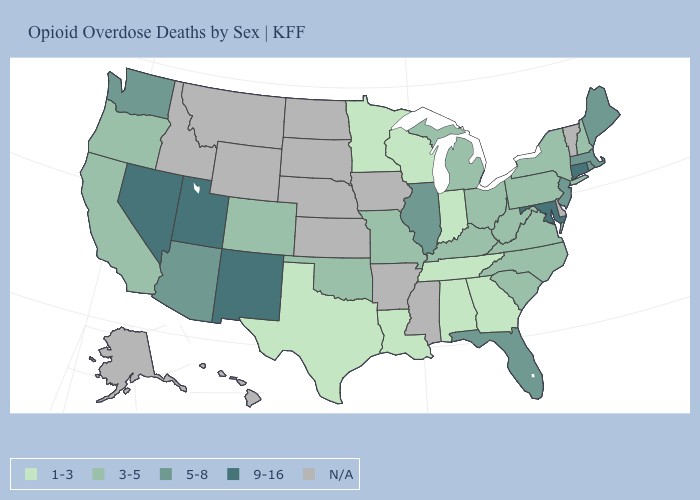What is the value of Connecticut?
Concise answer only. 9-16. Which states have the highest value in the USA?
Keep it brief. Connecticut, Maryland, Nevada, New Mexico, Utah. Does the first symbol in the legend represent the smallest category?
Quick response, please. Yes. What is the value of New York?
Short answer required. 3-5. Which states hav the highest value in the West?
Quick response, please. Nevada, New Mexico, Utah. Name the states that have a value in the range N/A?
Quick response, please. Alaska, Arkansas, Delaware, Hawaii, Idaho, Iowa, Kansas, Mississippi, Montana, Nebraska, North Dakota, South Dakota, Vermont, Wyoming. Among the states that border Kansas , which have the lowest value?
Answer briefly. Colorado, Missouri, Oklahoma. What is the value of Michigan?
Write a very short answer. 3-5. What is the highest value in states that border California?
Give a very brief answer. 9-16. Name the states that have a value in the range 1-3?
Short answer required. Alabama, Georgia, Indiana, Louisiana, Minnesota, Tennessee, Texas, Wisconsin. What is the highest value in states that border Washington?
Short answer required. 3-5. Name the states that have a value in the range 1-3?
Be succinct. Alabama, Georgia, Indiana, Louisiana, Minnesota, Tennessee, Texas, Wisconsin. Name the states that have a value in the range N/A?
Give a very brief answer. Alaska, Arkansas, Delaware, Hawaii, Idaho, Iowa, Kansas, Mississippi, Montana, Nebraska, North Dakota, South Dakota, Vermont, Wyoming. What is the lowest value in the USA?
Give a very brief answer. 1-3. 